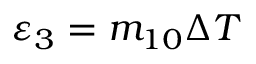Convert formula to latex. <formula><loc_0><loc_0><loc_500><loc_500>{ { \varepsilon } _ { 3 } } = { { m } _ { 1 0 } } \Delta T</formula> 